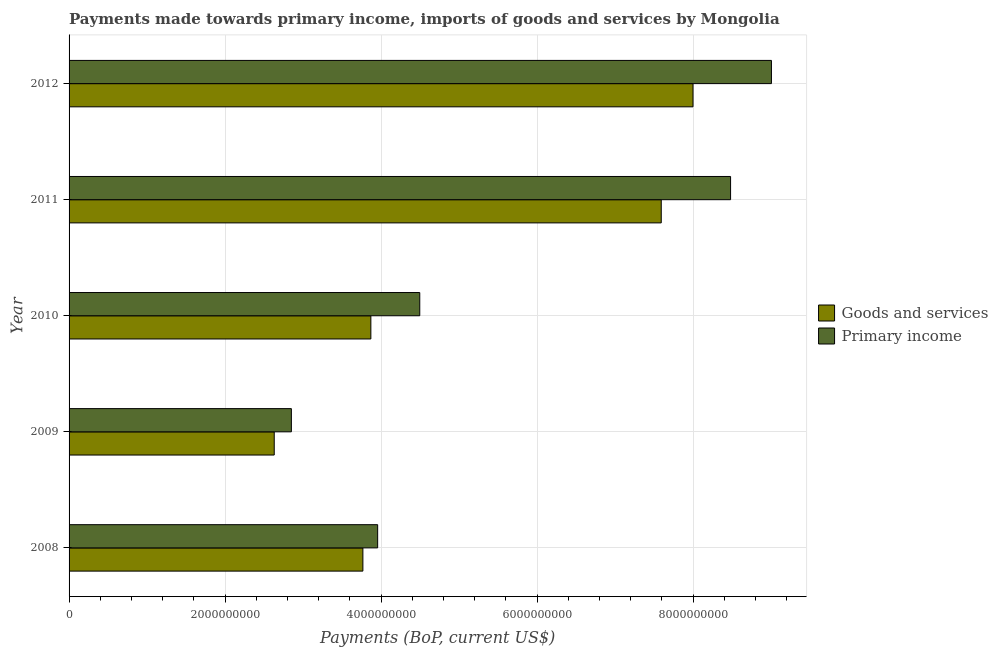How many different coloured bars are there?
Provide a short and direct response. 2. Are the number of bars per tick equal to the number of legend labels?
Provide a succinct answer. Yes. How many bars are there on the 4th tick from the bottom?
Your answer should be very brief. 2. What is the label of the 2nd group of bars from the top?
Provide a succinct answer. 2011. What is the payments made towards primary income in 2009?
Provide a succinct answer. 2.85e+09. Across all years, what is the maximum payments made towards goods and services?
Offer a very short reply. 8.00e+09. Across all years, what is the minimum payments made towards primary income?
Provide a succinct answer. 2.85e+09. What is the total payments made towards primary income in the graph?
Give a very brief answer. 2.88e+1. What is the difference between the payments made towards goods and services in 2010 and that in 2011?
Keep it short and to the point. -3.72e+09. What is the difference between the payments made towards goods and services in 2010 and the payments made towards primary income in 2009?
Provide a short and direct response. 1.02e+09. What is the average payments made towards goods and services per year?
Your answer should be compact. 5.17e+09. In the year 2010, what is the difference between the payments made towards goods and services and payments made towards primary income?
Give a very brief answer. -6.27e+08. In how many years, is the payments made towards primary income greater than 800000000 US$?
Keep it short and to the point. 5. What is the ratio of the payments made towards goods and services in 2010 to that in 2012?
Your answer should be compact. 0.48. Is the payments made towards primary income in 2008 less than that in 2011?
Give a very brief answer. Yes. What is the difference between the highest and the second highest payments made towards primary income?
Make the answer very short. 5.24e+08. What is the difference between the highest and the lowest payments made towards primary income?
Keep it short and to the point. 6.15e+09. In how many years, is the payments made towards primary income greater than the average payments made towards primary income taken over all years?
Your answer should be compact. 2. Is the sum of the payments made towards primary income in 2010 and 2012 greater than the maximum payments made towards goods and services across all years?
Make the answer very short. Yes. What does the 1st bar from the top in 2012 represents?
Offer a very short reply. Primary income. What does the 2nd bar from the bottom in 2010 represents?
Your answer should be compact. Primary income. How many years are there in the graph?
Give a very brief answer. 5. Does the graph contain any zero values?
Ensure brevity in your answer.  No. How many legend labels are there?
Give a very brief answer. 2. How are the legend labels stacked?
Make the answer very short. Vertical. What is the title of the graph?
Offer a terse response. Payments made towards primary income, imports of goods and services by Mongolia. What is the label or title of the X-axis?
Provide a succinct answer. Payments (BoP, current US$). What is the Payments (BoP, current US$) in Goods and services in 2008?
Provide a short and direct response. 3.77e+09. What is the Payments (BoP, current US$) of Primary income in 2008?
Make the answer very short. 3.96e+09. What is the Payments (BoP, current US$) of Goods and services in 2009?
Your response must be concise. 2.63e+09. What is the Payments (BoP, current US$) of Primary income in 2009?
Provide a short and direct response. 2.85e+09. What is the Payments (BoP, current US$) in Goods and services in 2010?
Provide a short and direct response. 3.87e+09. What is the Payments (BoP, current US$) in Primary income in 2010?
Provide a short and direct response. 4.50e+09. What is the Payments (BoP, current US$) of Goods and services in 2011?
Your answer should be compact. 7.59e+09. What is the Payments (BoP, current US$) of Primary income in 2011?
Offer a very short reply. 8.48e+09. What is the Payments (BoP, current US$) in Goods and services in 2012?
Ensure brevity in your answer.  8.00e+09. What is the Payments (BoP, current US$) of Primary income in 2012?
Provide a succinct answer. 9.00e+09. Across all years, what is the maximum Payments (BoP, current US$) of Goods and services?
Make the answer very short. 8.00e+09. Across all years, what is the maximum Payments (BoP, current US$) of Primary income?
Keep it short and to the point. 9.00e+09. Across all years, what is the minimum Payments (BoP, current US$) in Goods and services?
Offer a terse response. 2.63e+09. Across all years, what is the minimum Payments (BoP, current US$) of Primary income?
Offer a terse response. 2.85e+09. What is the total Payments (BoP, current US$) of Goods and services in the graph?
Offer a terse response. 2.59e+1. What is the total Payments (BoP, current US$) in Primary income in the graph?
Provide a short and direct response. 2.88e+1. What is the difference between the Payments (BoP, current US$) of Goods and services in 2008 and that in 2009?
Ensure brevity in your answer.  1.14e+09. What is the difference between the Payments (BoP, current US$) of Primary income in 2008 and that in 2009?
Your answer should be compact. 1.11e+09. What is the difference between the Payments (BoP, current US$) in Goods and services in 2008 and that in 2010?
Your answer should be very brief. -1.02e+08. What is the difference between the Payments (BoP, current US$) in Primary income in 2008 and that in 2010?
Make the answer very short. -5.40e+08. What is the difference between the Payments (BoP, current US$) of Goods and services in 2008 and that in 2011?
Your response must be concise. -3.82e+09. What is the difference between the Payments (BoP, current US$) of Primary income in 2008 and that in 2011?
Offer a terse response. -4.52e+09. What is the difference between the Payments (BoP, current US$) in Goods and services in 2008 and that in 2012?
Your answer should be compact. -4.23e+09. What is the difference between the Payments (BoP, current US$) of Primary income in 2008 and that in 2012?
Your answer should be compact. -5.05e+09. What is the difference between the Payments (BoP, current US$) in Goods and services in 2009 and that in 2010?
Provide a succinct answer. -1.24e+09. What is the difference between the Payments (BoP, current US$) of Primary income in 2009 and that in 2010?
Your response must be concise. -1.65e+09. What is the difference between the Payments (BoP, current US$) in Goods and services in 2009 and that in 2011?
Your answer should be very brief. -4.96e+09. What is the difference between the Payments (BoP, current US$) of Primary income in 2009 and that in 2011?
Make the answer very short. -5.63e+09. What is the difference between the Payments (BoP, current US$) in Goods and services in 2009 and that in 2012?
Keep it short and to the point. -5.37e+09. What is the difference between the Payments (BoP, current US$) of Primary income in 2009 and that in 2012?
Provide a succinct answer. -6.15e+09. What is the difference between the Payments (BoP, current US$) of Goods and services in 2010 and that in 2011?
Your response must be concise. -3.72e+09. What is the difference between the Payments (BoP, current US$) in Primary income in 2010 and that in 2011?
Your response must be concise. -3.98e+09. What is the difference between the Payments (BoP, current US$) in Goods and services in 2010 and that in 2012?
Keep it short and to the point. -4.13e+09. What is the difference between the Payments (BoP, current US$) of Primary income in 2010 and that in 2012?
Your answer should be compact. -4.51e+09. What is the difference between the Payments (BoP, current US$) of Goods and services in 2011 and that in 2012?
Your answer should be very brief. -4.07e+08. What is the difference between the Payments (BoP, current US$) of Primary income in 2011 and that in 2012?
Provide a succinct answer. -5.24e+08. What is the difference between the Payments (BoP, current US$) in Goods and services in 2008 and the Payments (BoP, current US$) in Primary income in 2009?
Ensure brevity in your answer.  9.17e+08. What is the difference between the Payments (BoP, current US$) in Goods and services in 2008 and the Payments (BoP, current US$) in Primary income in 2010?
Your response must be concise. -7.29e+08. What is the difference between the Payments (BoP, current US$) in Goods and services in 2008 and the Payments (BoP, current US$) in Primary income in 2011?
Give a very brief answer. -4.71e+09. What is the difference between the Payments (BoP, current US$) in Goods and services in 2008 and the Payments (BoP, current US$) in Primary income in 2012?
Provide a short and direct response. -5.24e+09. What is the difference between the Payments (BoP, current US$) of Goods and services in 2009 and the Payments (BoP, current US$) of Primary income in 2010?
Give a very brief answer. -1.87e+09. What is the difference between the Payments (BoP, current US$) in Goods and services in 2009 and the Payments (BoP, current US$) in Primary income in 2011?
Make the answer very short. -5.85e+09. What is the difference between the Payments (BoP, current US$) of Goods and services in 2009 and the Payments (BoP, current US$) of Primary income in 2012?
Offer a terse response. -6.37e+09. What is the difference between the Payments (BoP, current US$) in Goods and services in 2010 and the Payments (BoP, current US$) in Primary income in 2011?
Your answer should be compact. -4.61e+09. What is the difference between the Payments (BoP, current US$) in Goods and services in 2010 and the Payments (BoP, current US$) in Primary income in 2012?
Your answer should be very brief. -5.14e+09. What is the difference between the Payments (BoP, current US$) of Goods and services in 2011 and the Payments (BoP, current US$) of Primary income in 2012?
Your answer should be compact. -1.41e+09. What is the average Payments (BoP, current US$) in Goods and services per year?
Your response must be concise. 5.17e+09. What is the average Payments (BoP, current US$) in Primary income per year?
Your response must be concise. 5.76e+09. In the year 2008, what is the difference between the Payments (BoP, current US$) in Goods and services and Payments (BoP, current US$) in Primary income?
Provide a short and direct response. -1.89e+08. In the year 2009, what is the difference between the Payments (BoP, current US$) of Goods and services and Payments (BoP, current US$) of Primary income?
Make the answer very short. -2.20e+08. In the year 2010, what is the difference between the Payments (BoP, current US$) in Goods and services and Payments (BoP, current US$) in Primary income?
Offer a terse response. -6.27e+08. In the year 2011, what is the difference between the Payments (BoP, current US$) of Goods and services and Payments (BoP, current US$) of Primary income?
Keep it short and to the point. -8.89e+08. In the year 2012, what is the difference between the Payments (BoP, current US$) in Goods and services and Payments (BoP, current US$) in Primary income?
Your response must be concise. -1.01e+09. What is the ratio of the Payments (BoP, current US$) in Goods and services in 2008 to that in 2009?
Your answer should be compact. 1.43. What is the ratio of the Payments (BoP, current US$) in Primary income in 2008 to that in 2009?
Your response must be concise. 1.39. What is the ratio of the Payments (BoP, current US$) of Goods and services in 2008 to that in 2010?
Your response must be concise. 0.97. What is the ratio of the Payments (BoP, current US$) in Primary income in 2008 to that in 2010?
Your answer should be very brief. 0.88. What is the ratio of the Payments (BoP, current US$) in Goods and services in 2008 to that in 2011?
Ensure brevity in your answer.  0.5. What is the ratio of the Payments (BoP, current US$) of Primary income in 2008 to that in 2011?
Your response must be concise. 0.47. What is the ratio of the Payments (BoP, current US$) of Goods and services in 2008 to that in 2012?
Make the answer very short. 0.47. What is the ratio of the Payments (BoP, current US$) of Primary income in 2008 to that in 2012?
Your response must be concise. 0.44. What is the ratio of the Payments (BoP, current US$) of Goods and services in 2009 to that in 2010?
Ensure brevity in your answer.  0.68. What is the ratio of the Payments (BoP, current US$) of Primary income in 2009 to that in 2010?
Your answer should be very brief. 0.63. What is the ratio of the Payments (BoP, current US$) of Goods and services in 2009 to that in 2011?
Offer a very short reply. 0.35. What is the ratio of the Payments (BoP, current US$) of Primary income in 2009 to that in 2011?
Make the answer very short. 0.34. What is the ratio of the Payments (BoP, current US$) in Goods and services in 2009 to that in 2012?
Your answer should be very brief. 0.33. What is the ratio of the Payments (BoP, current US$) of Primary income in 2009 to that in 2012?
Offer a terse response. 0.32. What is the ratio of the Payments (BoP, current US$) of Goods and services in 2010 to that in 2011?
Offer a very short reply. 0.51. What is the ratio of the Payments (BoP, current US$) in Primary income in 2010 to that in 2011?
Offer a terse response. 0.53. What is the ratio of the Payments (BoP, current US$) of Goods and services in 2010 to that in 2012?
Make the answer very short. 0.48. What is the ratio of the Payments (BoP, current US$) in Primary income in 2010 to that in 2012?
Your answer should be very brief. 0.5. What is the ratio of the Payments (BoP, current US$) in Goods and services in 2011 to that in 2012?
Provide a short and direct response. 0.95. What is the ratio of the Payments (BoP, current US$) in Primary income in 2011 to that in 2012?
Give a very brief answer. 0.94. What is the difference between the highest and the second highest Payments (BoP, current US$) in Goods and services?
Your response must be concise. 4.07e+08. What is the difference between the highest and the second highest Payments (BoP, current US$) of Primary income?
Your answer should be compact. 5.24e+08. What is the difference between the highest and the lowest Payments (BoP, current US$) of Goods and services?
Offer a terse response. 5.37e+09. What is the difference between the highest and the lowest Payments (BoP, current US$) of Primary income?
Your response must be concise. 6.15e+09. 